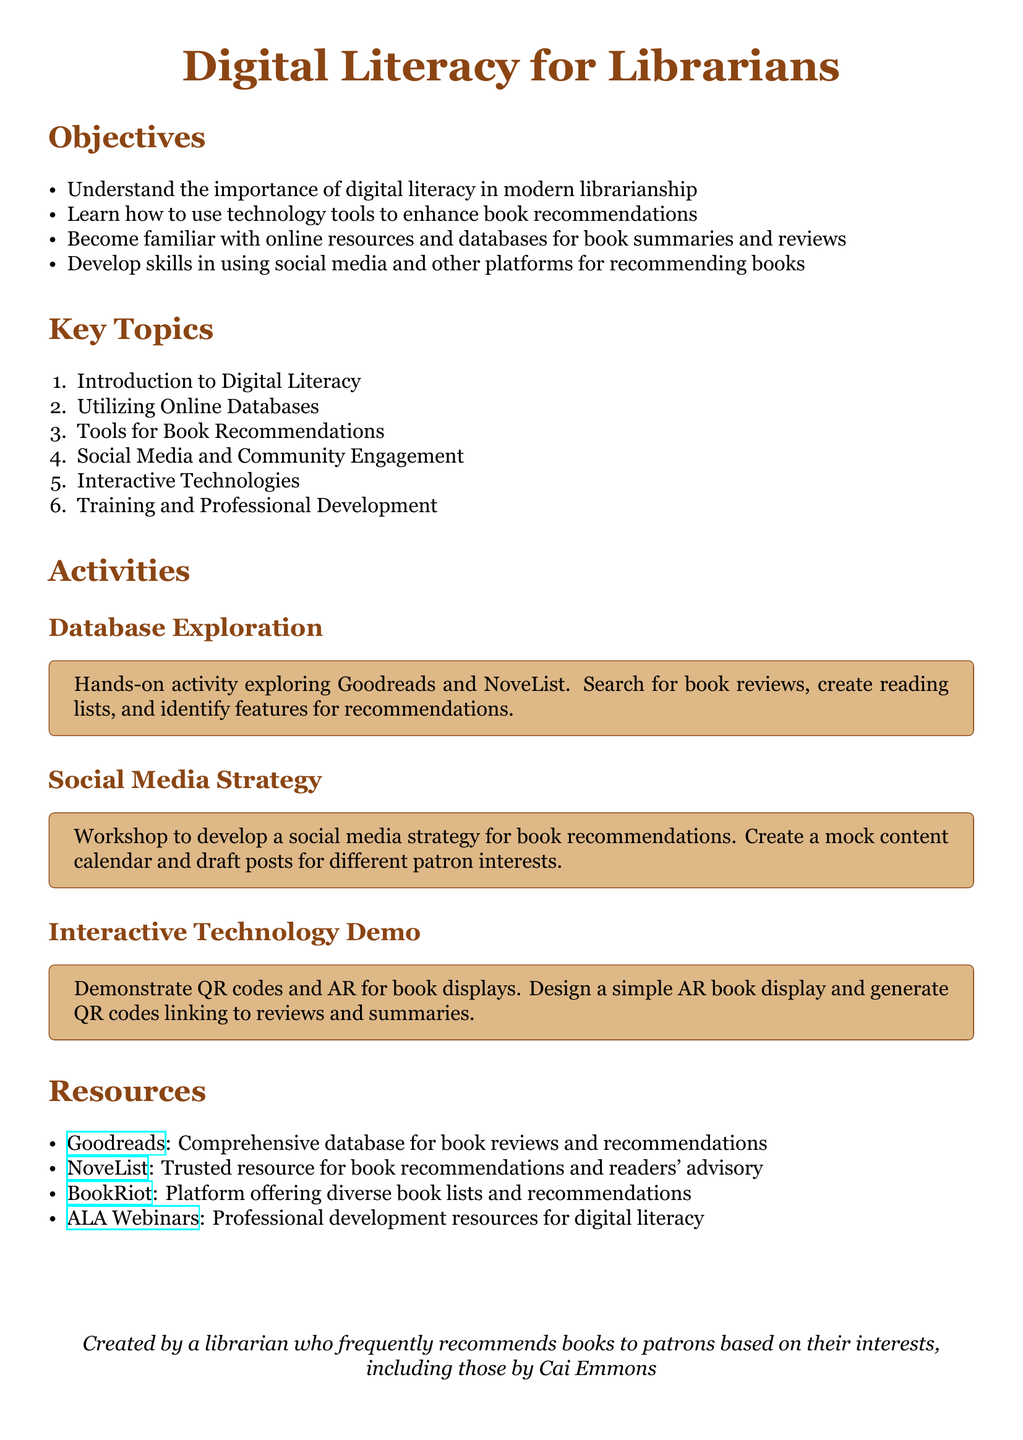What is the main title of the lesson plan? The main title is found at the top of the document.
Answer: Digital Literacy for Librarians How many objectives are listed in the document? The number of objectives can be counted from the list provided in the document.
Answer: Four What online resource is mentioned for book reviews besides Goodreads? The resource can be found in the list of resources in the document.
Answer: NoveList What activity involves a workshop for developing a social media strategy? The specific activity can be identified from the activities section.
Answer: Social Media Strategy What type of technology is demonstrated in the interactive activity? The technology being demoed can be found in the activities section.
Answer: QR codes and AR Which skill is emphasized regarding community engagement? This can be discerned from the key topics listed in the document.
Answer: Social Media What is the objective of learning online resources and databases? The aims are outlined in the objectives section.
Answer: Enhance book recommendations What is the format for the resources listed? This can be seen from the layout of the resources section in the document.
Answer: Bullet points 